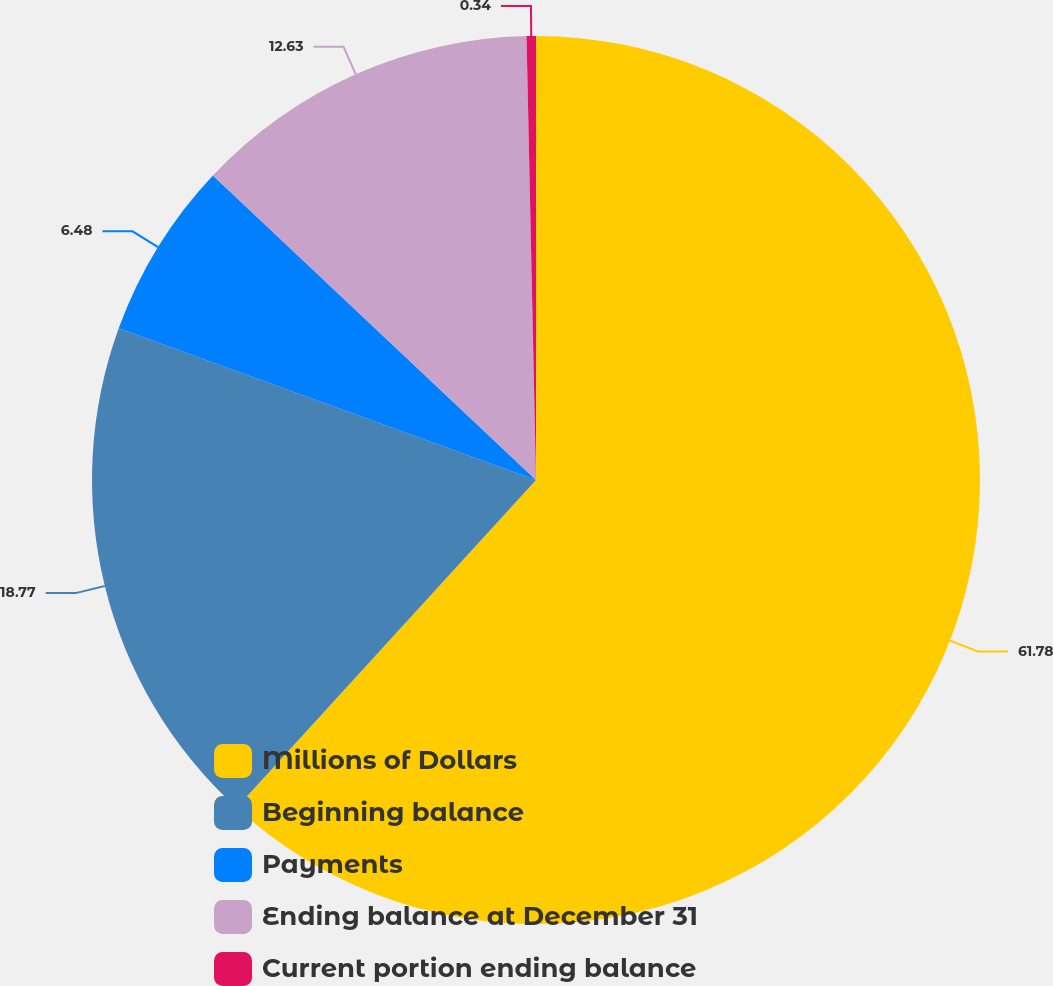Convert chart to OTSL. <chart><loc_0><loc_0><loc_500><loc_500><pie_chart><fcel>Millions of Dollars<fcel>Beginning balance<fcel>Payments<fcel>Ending balance at December 31<fcel>Current portion ending balance<nl><fcel>61.78%<fcel>18.77%<fcel>6.48%<fcel>12.63%<fcel>0.34%<nl></chart> 